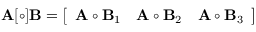<formula> <loc_0><loc_0><loc_500><loc_500>A [ \circ ] B = \left [ { \begin{array} { c c c } { A \circ B _ { 1 } } & { A \circ B _ { 2 } } & { A \circ B _ { 3 } } \end{array} } \right ]</formula> 